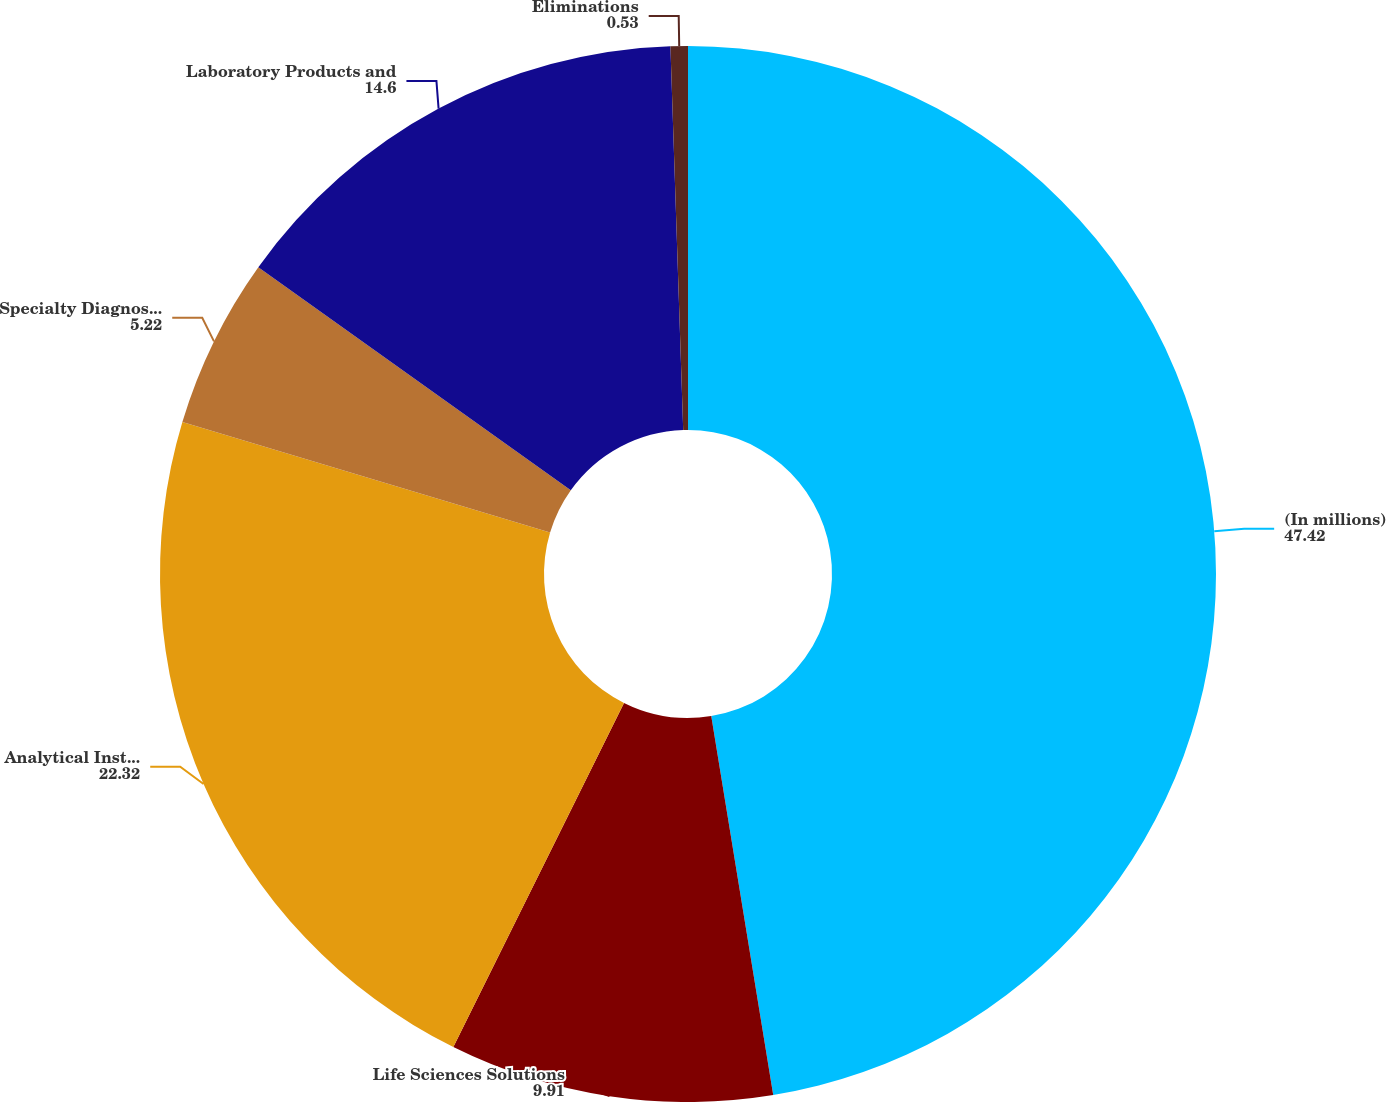<chart> <loc_0><loc_0><loc_500><loc_500><pie_chart><fcel>(In millions)<fcel>Life Sciences Solutions<fcel>Analytical Instruments<fcel>Specialty Diagnostics<fcel>Laboratory Products and<fcel>Eliminations<nl><fcel>47.42%<fcel>9.91%<fcel>22.32%<fcel>5.22%<fcel>14.6%<fcel>0.53%<nl></chart> 